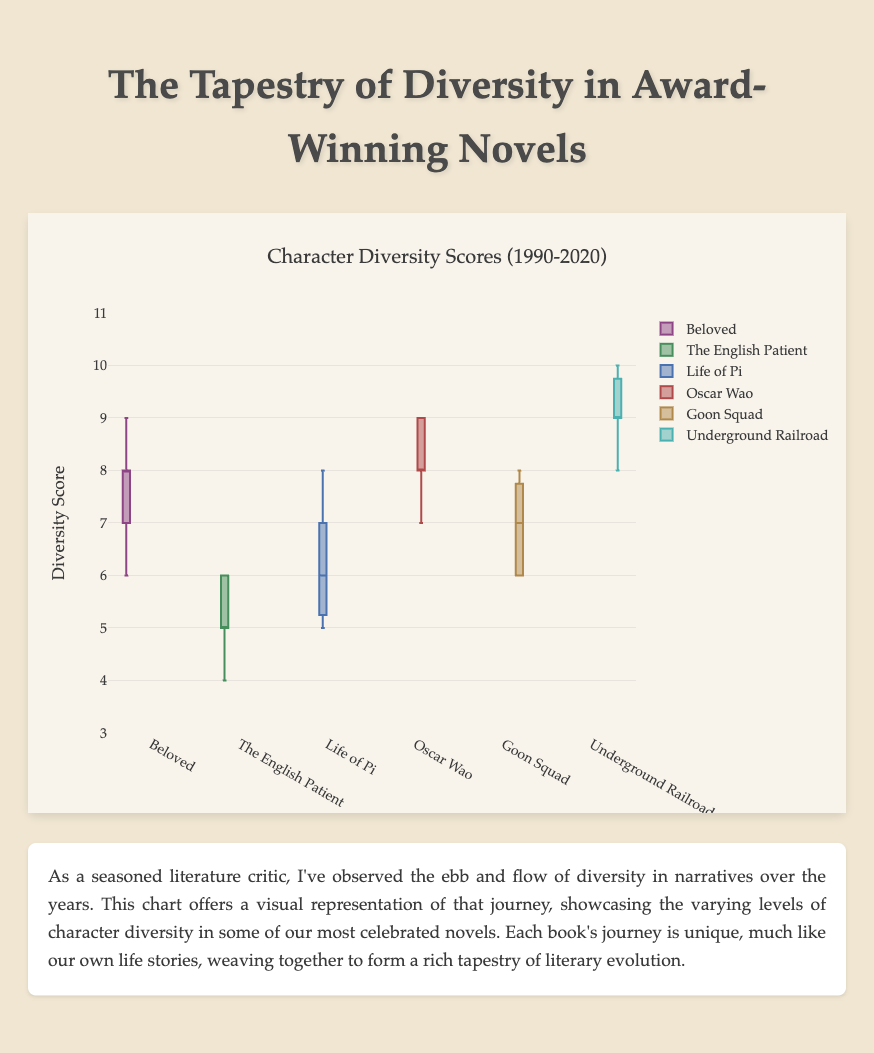What is the title of the chart? The title is written at the top and gives an overview of what the chart is about. Look at the header; it reads "Character Diversity Scores (1990-2020)".
Answer: Character Diversity Scores (1990-2020) Which book shows the highest median diversity score? To find the median, look at the line inside each box plot, which represents the median value. The highest median line is seen in "The Underground Railroad".
Answer: The Underground Railroad What is the range of the diversity scores for "Life of Pi"? The range can be identified by noting the minimum and maximum values of the box plot for "Life of Pi". The lowest whisker extends to 5, and the highest goes to 8. So, 8 - 5 = 3.
Answer: 3 Which book has the most consistent diversity score over time? Consistency can be seen by looking for the smallest interquartile range (IQR), the distance between the top and bottom of the box. "The English Patient" has a relatively small IQR, meaning its scores are the most consistent.
Answer: The English Patient How does the diversity score of "Beloved" compare to "A Visit from the Goon Squad"? Compare the median lines of both books. "Beloved" has a higher median than "A Visit from the Goon Squad".
Answer: Beloved has a higher median What is the highest recorded diversity score among all novels? The highest individual score is indicated by the top whisker or outlier point. "The Underground Railroad" reaches the highest score of 10.
Answer: 10 Which novel shows the greatest increase in diversity score over time? We need to subtract the earliest from the latest diversity score for each novel and compare. "The Underground Railroad" increases from 8 to 10, which is the largest increase of 2 points.
Answer: The Underground Railroad In which year does "Life of Pi" have its lowest diversity score? Look at the distribution of scores for "Life of Pi" and their corresponding years. The lowest score is 5, it appears in 1990 and 1995. Since it's requested to pick one, "1990" is selected here.
Answer: 1990 Which books have diversity scores higher than 8 in any year? Look for whiskers or points above 8. "Beloved", "The Brief Wondrous Life of Oscar Wao", "A Visit from the Goon Squad", and "The Underground Railroad" surpass this threshold.
Answer: Beloved, The Brief Wondrous Life of Oscar Wao, A Visit from the Goon Squad, The Underground Railroad 